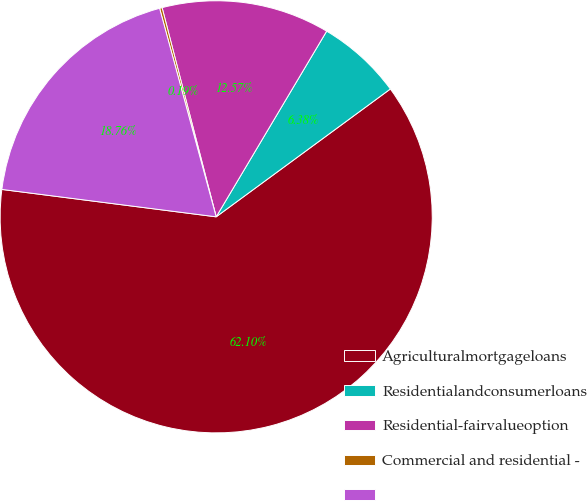Convert chart to OTSL. <chart><loc_0><loc_0><loc_500><loc_500><pie_chart><fcel>Agriculturalmortgageloans<fcel>Residentialandconsumerloans<fcel>Residential-fairvalueoption<fcel>Commercial and residential -<fcel>Unnamed: 4<nl><fcel>62.1%<fcel>6.38%<fcel>12.57%<fcel>0.19%<fcel>18.76%<nl></chart> 